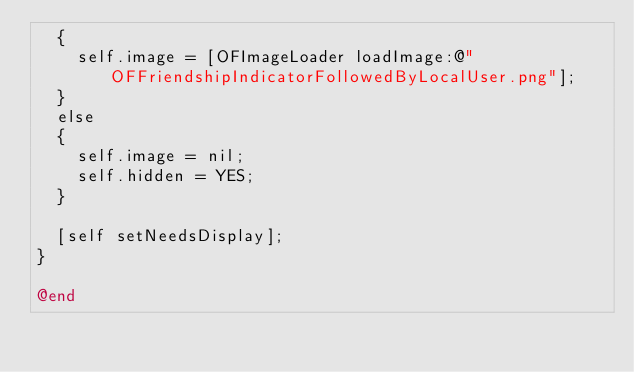<code> <loc_0><loc_0><loc_500><loc_500><_ObjectiveC_>	{
		self.image = [OFImageLoader loadImage:@"OFFriendshipIndicatorFollowedByLocalUser.png"];
	}
	else
	{
		self.image = nil;
		self.hidden = YES;
	}

	[self setNeedsDisplay];
}

@end
</code> 